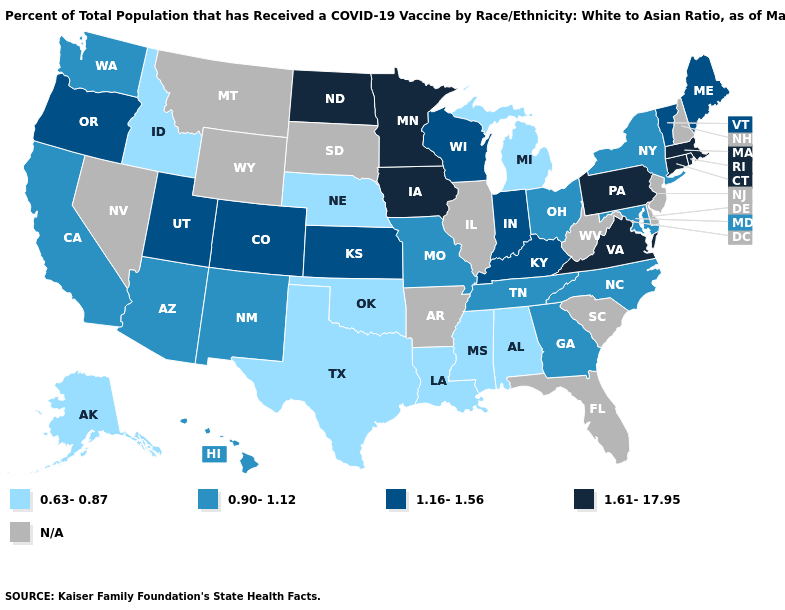Among the states that border Maryland , which have the lowest value?
Write a very short answer. Pennsylvania, Virginia. Does Iowa have the highest value in the MidWest?
Concise answer only. Yes. Does North Dakota have the lowest value in the USA?
Be succinct. No. Which states have the lowest value in the USA?
Keep it brief. Alabama, Alaska, Idaho, Louisiana, Michigan, Mississippi, Nebraska, Oklahoma, Texas. What is the value of Massachusetts?
Give a very brief answer. 1.61-17.95. Name the states that have a value in the range 0.90-1.12?
Be succinct. Arizona, California, Georgia, Hawaii, Maryland, Missouri, New Mexico, New York, North Carolina, Ohio, Tennessee, Washington. Is the legend a continuous bar?
Answer briefly. No. What is the highest value in the USA?
Short answer required. 1.61-17.95. Which states have the lowest value in the USA?
Quick response, please. Alabama, Alaska, Idaho, Louisiana, Michigan, Mississippi, Nebraska, Oklahoma, Texas. How many symbols are there in the legend?
Give a very brief answer. 5. Does the map have missing data?
Answer briefly. Yes. Does Colorado have the highest value in the West?
Quick response, please. Yes. What is the value of South Dakota?
Concise answer only. N/A. What is the lowest value in the West?
Give a very brief answer. 0.63-0.87. Name the states that have a value in the range 0.90-1.12?
Answer briefly. Arizona, California, Georgia, Hawaii, Maryland, Missouri, New Mexico, New York, North Carolina, Ohio, Tennessee, Washington. 